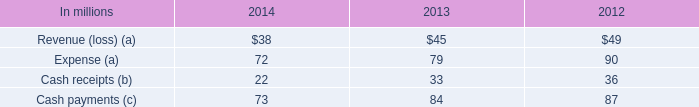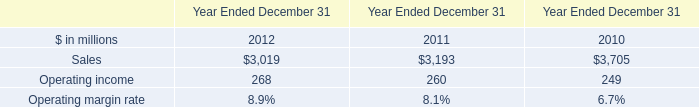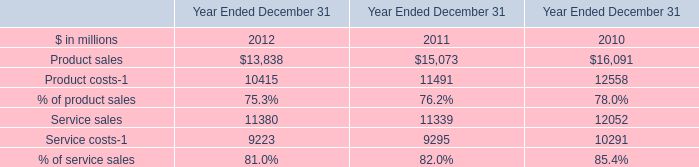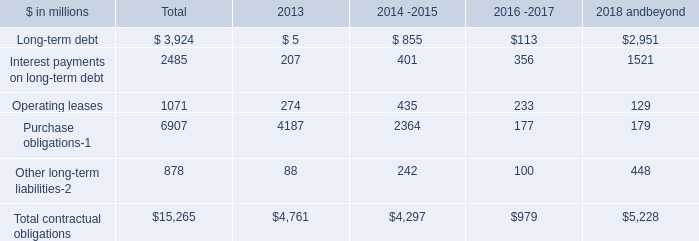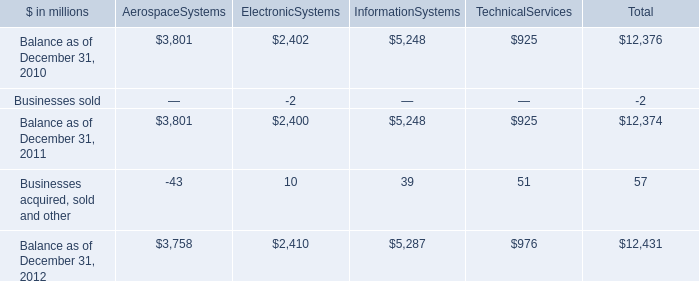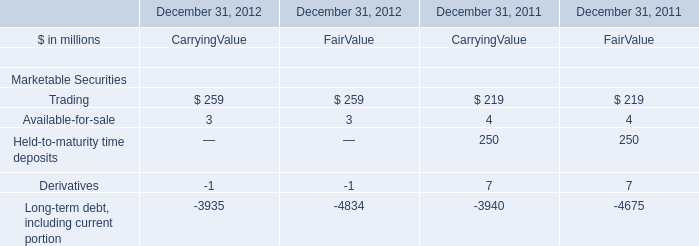What is the average amount of Service costs of Year Ended December 31 2010, and Balance as of December 31, 2011 of AerospaceSystems ? 
Computations: ((10291.0 + 3801.0) / 2)
Answer: 7046.0. 